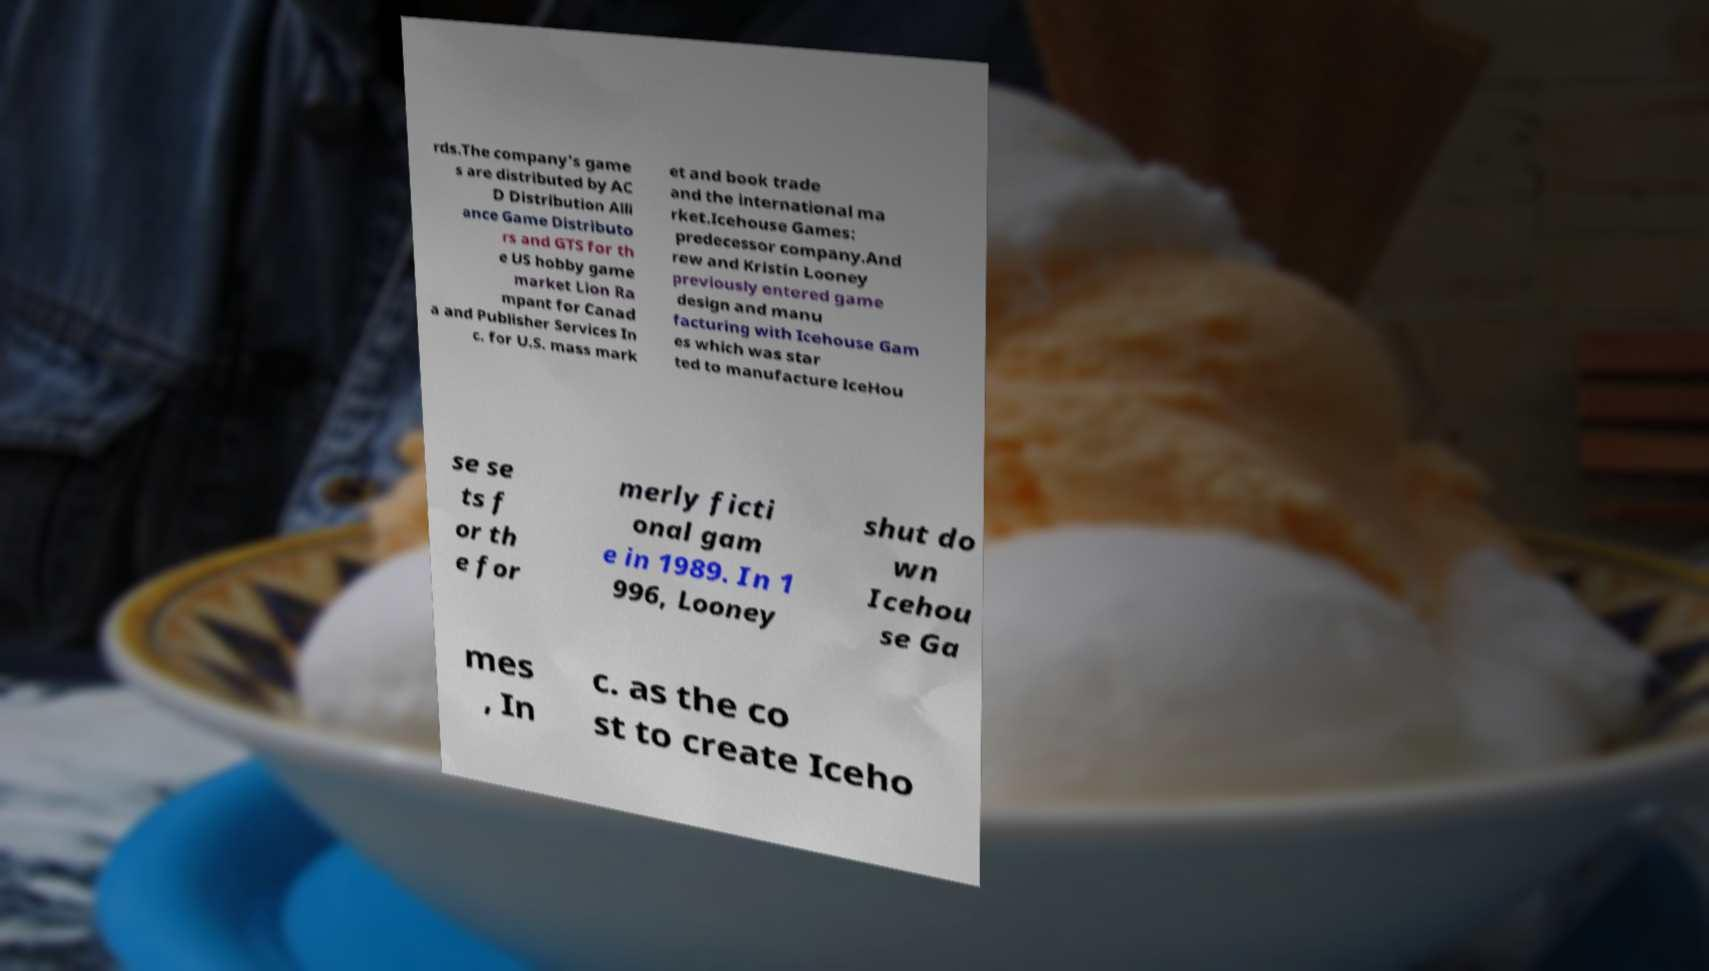For documentation purposes, I need the text within this image transcribed. Could you provide that? rds.The company's game s are distributed by AC D Distribution Alli ance Game Distributo rs and GTS for th e US hobby game market Lion Ra mpant for Canad a and Publisher Services In c. for U.S. mass mark et and book trade and the international ma rket.Icehouse Games: predecessor company.And rew and Kristin Looney previously entered game design and manu facturing with Icehouse Gam es which was star ted to manufacture IceHou se se ts f or th e for merly ficti onal gam e in 1989. In 1 996, Looney shut do wn Icehou se Ga mes , In c. as the co st to create Iceho 